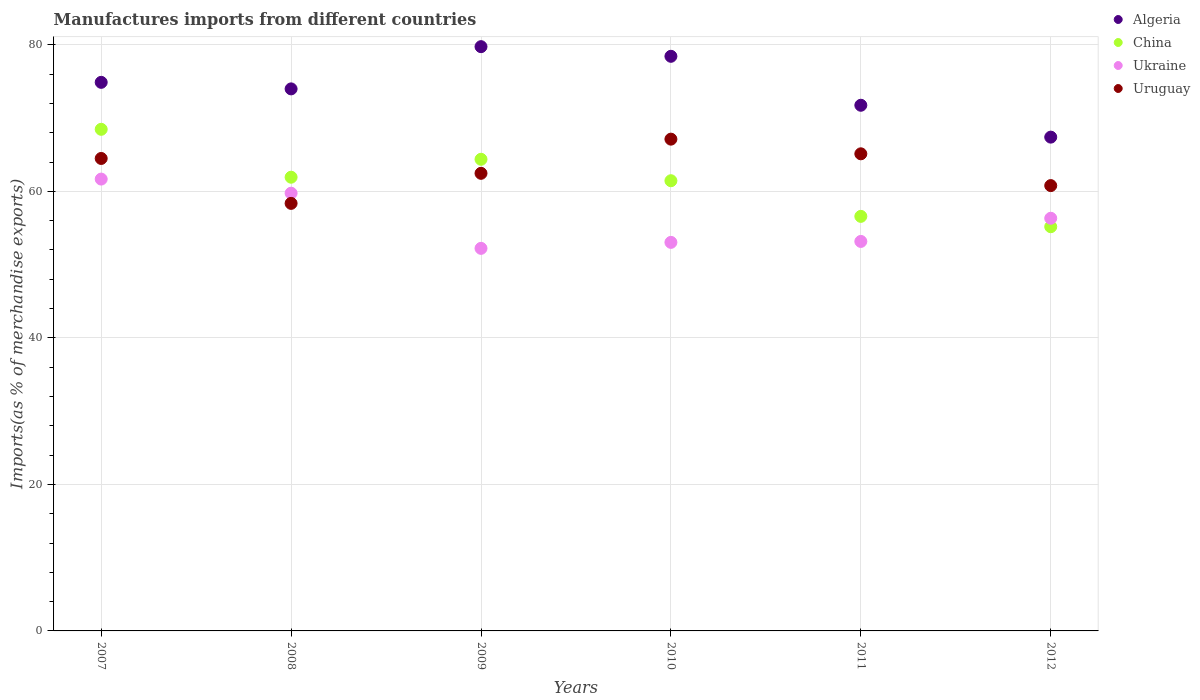How many different coloured dotlines are there?
Ensure brevity in your answer.  4. Is the number of dotlines equal to the number of legend labels?
Offer a very short reply. Yes. What is the percentage of imports to different countries in Uruguay in 2012?
Keep it short and to the point. 60.79. Across all years, what is the maximum percentage of imports to different countries in China?
Your answer should be very brief. 68.47. Across all years, what is the minimum percentage of imports to different countries in China?
Offer a very short reply. 55.17. What is the total percentage of imports to different countries in Uruguay in the graph?
Offer a very short reply. 378.35. What is the difference between the percentage of imports to different countries in Algeria in 2008 and that in 2010?
Provide a short and direct response. -4.45. What is the difference between the percentage of imports to different countries in Ukraine in 2011 and the percentage of imports to different countries in Algeria in 2012?
Offer a terse response. -14.24. What is the average percentage of imports to different countries in China per year?
Offer a terse response. 61.33. In the year 2007, what is the difference between the percentage of imports to different countries in Uruguay and percentage of imports to different countries in Ukraine?
Your response must be concise. 2.81. In how many years, is the percentage of imports to different countries in Uruguay greater than 32 %?
Provide a succinct answer. 6. What is the ratio of the percentage of imports to different countries in Uruguay in 2008 to that in 2009?
Provide a succinct answer. 0.93. Is the percentage of imports to different countries in Algeria in 2008 less than that in 2011?
Provide a succinct answer. No. Is the difference between the percentage of imports to different countries in Uruguay in 2008 and 2012 greater than the difference between the percentage of imports to different countries in Ukraine in 2008 and 2012?
Give a very brief answer. No. What is the difference between the highest and the second highest percentage of imports to different countries in China?
Offer a terse response. 4.09. What is the difference between the highest and the lowest percentage of imports to different countries in Ukraine?
Ensure brevity in your answer.  9.46. Is the sum of the percentage of imports to different countries in China in 2008 and 2012 greater than the maximum percentage of imports to different countries in Ukraine across all years?
Keep it short and to the point. Yes. Is it the case that in every year, the sum of the percentage of imports to different countries in China and percentage of imports to different countries in Uruguay  is greater than the sum of percentage of imports to different countries in Ukraine and percentage of imports to different countries in Algeria?
Your answer should be compact. No. Is the percentage of imports to different countries in China strictly less than the percentage of imports to different countries in Algeria over the years?
Offer a terse response. Yes. How many dotlines are there?
Provide a short and direct response. 4. Are the values on the major ticks of Y-axis written in scientific E-notation?
Keep it short and to the point. No. Does the graph contain grids?
Keep it short and to the point. Yes. How many legend labels are there?
Give a very brief answer. 4. What is the title of the graph?
Offer a terse response. Manufactures imports from different countries. What is the label or title of the Y-axis?
Provide a succinct answer. Imports(as % of merchandise exports). What is the Imports(as % of merchandise exports) of Algeria in 2007?
Provide a succinct answer. 74.88. What is the Imports(as % of merchandise exports) of China in 2007?
Your answer should be compact. 68.47. What is the Imports(as % of merchandise exports) of Ukraine in 2007?
Keep it short and to the point. 61.68. What is the Imports(as % of merchandise exports) of Uruguay in 2007?
Give a very brief answer. 64.49. What is the Imports(as % of merchandise exports) of Algeria in 2008?
Keep it short and to the point. 73.99. What is the Imports(as % of merchandise exports) in China in 2008?
Provide a short and direct response. 61.93. What is the Imports(as % of merchandise exports) in Ukraine in 2008?
Your response must be concise. 59.75. What is the Imports(as % of merchandise exports) in Uruguay in 2008?
Provide a short and direct response. 58.36. What is the Imports(as % of merchandise exports) of Algeria in 2009?
Provide a short and direct response. 79.75. What is the Imports(as % of merchandise exports) in China in 2009?
Your response must be concise. 64.38. What is the Imports(as % of merchandise exports) in Ukraine in 2009?
Offer a terse response. 52.22. What is the Imports(as % of merchandise exports) of Uruguay in 2009?
Make the answer very short. 62.46. What is the Imports(as % of merchandise exports) in Algeria in 2010?
Offer a very short reply. 78.43. What is the Imports(as % of merchandise exports) in China in 2010?
Offer a terse response. 61.45. What is the Imports(as % of merchandise exports) in Ukraine in 2010?
Provide a short and direct response. 53.04. What is the Imports(as % of merchandise exports) in Uruguay in 2010?
Offer a very short reply. 67.13. What is the Imports(as % of merchandise exports) in Algeria in 2011?
Keep it short and to the point. 71.75. What is the Imports(as % of merchandise exports) in China in 2011?
Provide a short and direct response. 56.59. What is the Imports(as % of merchandise exports) in Ukraine in 2011?
Your answer should be very brief. 53.16. What is the Imports(as % of merchandise exports) in Uruguay in 2011?
Offer a terse response. 65.12. What is the Imports(as % of merchandise exports) of Algeria in 2012?
Your answer should be very brief. 67.4. What is the Imports(as % of merchandise exports) in China in 2012?
Offer a very short reply. 55.17. What is the Imports(as % of merchandise exports) in Ukraine in 2012?
Offer a very short reply. 56.33. What is the Imports(as % of merchandise exports) of Uruguay in 2012?
Give a very brief answer. 60.79. Across all years, what is the maximum Imports(as % of merchandise exports) of Algeria?
Your answer should be very brief. 79.75. Across all years, what is the maximum Imports(as % of merchandise exports) of China?
Ensure brevity in your answer.  68.47. Across all years, what is the maximum Imports(as % of merchandise exports) of Ukraine?
Give a very brief answer. 61.68. Across all years, what is the maximum Imports(as % of merchandise exports) in Uruguay?
Offer a terse response. 67.13. Across all years, what is the minimum Imports(as % of merchandise exports) of Algeria?
Your response must be concise. 67.4. Across all years, what is the minimum Imports(as % of merchandise exports) in China?
Give a very brief answer. 55.17. Across all years, what is the minimum Imports(as % of merchandise exports) of Ukraine?
Provide a short and direct response. 52.22. Across all years, what is the minimum Imports(as % of merchandise exports) of Uruguay?
Offer a very short reply. 58.36. What is the total Imports(as % of merchandise exports) of Algeria in the graph?
Your answer should be very brief. 446.2. What is the total Imports(as % of merchandise exports) in China in the graph?
Provide a short and direct response. 367.98. What is the total Imports(as % of merchandise exports) of Ukraine in the graph?
Ensure brevity in your answer.  336.17. What is the total Imports(as % of merchandise exports) of Uruguay in the graph?
Keep it short and to the point. 378.35. What is the difference between the Imports(as % of merchandise exports) in Algeria in 2007 and that in 2008?
Provide a succinct answer. 0.89. What is the difference between the Imports(as % of merchandise exports) in China in 2007 and that in 2008?
Your answer should be very brief. 6.54. What is the difference between the Imports(as % of merchandise exports) in Ukraine in 2007 and that in 2008?
Provide a succinct answer. 1.93. What is the difference between the Imports(as % of merchandise exports) of Uruguay in 2007 and that in 2008?
Your response must be concise. 6.13. What is the difference between the Imports(as % of merchandise exports) in Algeria in 2007 and that in 2009?
Offer a terse response. -4.87. What is the difference between the Imports(as % of merchandise exports) of China in 2007 and that in 2009?
Provide a short and direct response. 4.09. What is the difference between the Imports(as % of merchandise exports) in Ukraine in 2007 and that in 2009?
Your answer should be compact. 9.46. What is the difference between the Imports(as % of merchandise exports) in Uruguay in 2007 and that in 2009?
Your answer should be very brief. 2.03. What is the difference between the Imports(as % of merchandise exports) of Algeria in 2007 and that in 2010?
Your answer should be very brief. -3.55. What is the difference between the Imports(as % of merchandise exports) in China in 2007 and that in 2010?
Your answer should be compact. 7.02. What is the difference between the Imports(as % of merchandise exports) of Ukraine in 2007 and that in 2010?
Ensure brevity in your answer.  8.64. What is the difference between the Imports(as % of merchandise exports) of Uruguay in 2007 and that in 2010?
Keep it short and to the point. -2.64. What is the difference between the Imports(as % of merchandise exports) in Algeria in 2007 and that in 2011?
Your response must be concise. 3.13. What is the difference between the Imports(as % of merchandise exports) in China in 2007 and that in 2011?
Your answer should be very brief. 11.88. What is the difference between the Imports(as % of merchandise exports) of Ukraine in 2007 and that in 2011?
Your answer should be compact. 8.51. What is the difference between the Imports(as % of merchandise exports) of Uruguay in 2007 and that in 2011?
Provide a succinct answer. -0.64. What is the difference between the Imports(as % of merchandise exports) in Algeria in 2007 and that in 2012?
Offer a very short reply. 7.48. What is the difference between the Imports(as % of merchandise exports) in China in 2007 and that in 2012?
Keep it short and to the point. 13.3. What is the difference between the Imports(as % of merchandise exports) in Ukraine in 2007 and that in 2012?
Offer a terse response. 5.35. What is the difference between the Imports(as % of merchandise exports) of Uruguay in 2007 and that in 2012?
Make the answer very short. 3.7. What is the difference between the Imports(as % of merchandise exports) of Algeria in 2008 and that in 2009?
Provide a succinct answer. -5.76. What is the difference between the Imports(as % of merchandise exports) of China in 2008 and that in 2009?
Provide a succinct answer. -2.45. What is the difference between the Imports(as % of merchandise exports) of Ukraine in 2008 and that in 2009?
Give a very brief answer. 7.53. What is the difference between the Imports(as % of merchandise exports) of Uruguay in 2008 and that in 2009?
Give a very brief answer. -4.1. What is the difference between the Imports(as % of merchandise exports) of Algeria in 2008 and that in 2010?
Your answer should be very brief. -4.45. What is the difference between the Imports(as % of merchandise exports) in China in 2008 and that in 2010?
Offer a terse response. 0.48. What is the difference between the Imports(as % of merchandise exports) in Ukraine in 2008 and that in 2010?
Offer a very short reply. 6.71. What is the difference between the Imports(as % of merchandise exports) of Uruguay in 2008 and that in 2010?
Provide a short and direct response. -8.77. What is the difference between the Imports(as % of merchandise exports) of Algeria in 2008 and that in 2011?
Ensure brevity in your answer.  2.23. What is the difference between the Imports(as % of merchandise exports) in China in 2008 and that in 2011?
Provide a short and direct response. 5.34. What is the difference between the Imports(as % of merchandise exports) in Ukraine in 2008 and that in 2011?
Your answer should be very brief. 6.59. What is the difference between the Imports(as % of merchandise exports) of Uruguay in 2008 and that in 2011?
Offer a very short reply. -6.77. What is the difference between the Imports(as % of merchandise exports) of Algeria in 2008 and that in 2012?
Your response must be concise. 6.58. What is the difference between the Imports(as % of merchandise exports) in China in 2008 and that in 2012?
Keep it short and to the point. 6.76. What is the difference between the Imports(as % of merchandise exports) in Ukraine in 2008 and that in 2012?
Give a very brief answer. 3.42. What is the difference between the Imports(as % of merchandise exports) of Uruguay in 2008 and that in 2012?
Your response must be concise. -2.43. What is the difference between the Imports(as % of merchandise exports) of Algeria in 2009 and that in 2010?
Your answer should be compact. 1.32. What is the difference between the Imports(as % of merchandise exports) in China in 2009 and that in 2010?
Ensure brevity in your answer.  2.93. What is the difference between the Imports(as % of merchandise exports) of Ukraine in 2009 and that in 2010?
Give a very brief answer. -0.82. What is the difference between the Imports(as % of merchandise exports) of Uruguay in 2009 and that in 2010?
Your answer should be very brief. -4.66. What is the difference between the Imports(as % of merchandise exports) of Algeria in 2009 and that in 2011?
Your response must be concise. 8. What is the difference between the Imports(as % of merchandise exports) of China in 2009 and that in 2011?
Offer a terse response. 7.79. What is the difference between the Imports(as % of merchandise exports) of Ukraine in 2009 and that in 2011?
Provide a short and direct response. -0.95. What is the difference between the Imports(as % of merchandise exports) in Uruguay in 2009 and that in 2011?
Your answer should be very brief. -2.66. What is the difference between the Imports(as % of merchandise exports) of Algeria in 2009 and that in 2012?
Keep it short and to the point. 12.35. What is the difference between the Imports(as % of merchandise exports) in China in 2009 and that in 2012?
Give a very brief answer. 9.2. What is the difference between the Imports(as % of merchandise exports) in Ukraine in 2009 and that in 2012?
Offer a terse response. -4.11. What is the difference between the Imports(as % of merchandise exports) in Uruguay in 2009 and that in 2012?
Your response must be concise. 1.68. What is the difference between the Imports(as % of merchandise exports) in Algeria in 2010 and that in 2011?
Your answer should be very brief. 6.68. What is the difference between the Imports(as % of merchandise exports) in China in 2010 and that in 2011?
Offer a terse response. 4.87. What is the difference between the Imports(as % of merchandise exports) of Ukraine in 2010 and that in 2011?
Provide a succinct answer. -0.13. What is the difference between the Imports(as % of merchandise exports) of Uruguay in 2010 and that in 2011?
Offer a very short reply. 2. What is the difference between the Imports(as % of merchandise exports) in Algeria in 2010 and that in 2012?
Your response must be concise. 11.03. What is the difference between the Imports(as % of merchandise exports) of China in 2010 and that in 2012?
Your response must be concise. 6.28. What is the difference between the Imports(as % of merchandise exports) in Ukraine in 2010 and that in 2012?
Your response must be concise. -3.29. What is the difference between the Imports(as % of merchandise exports) in Uruguay in 2010 and that in 2012?
Provide a short and direct response. 6.34. What is the difference between the Imports(as % of merchandise exports) of Algeria in 2011 and that in 2012?
Your answer should be very brief. 4.35. What is the difference between the Imports(as % of merchandise exports) in China in 2011 and that in 2012?
Your answer should be very brief. 1.41. What is the difference between the Imports(as % of merchandise exports) of Ukraine in 2011 and that in 2012?
Your answer should be compact. -3.16. What is the difference between the Imports(as % of merchandise exports) of Uruguay in 2011 and that in 2012?
Make the answer very short. 4.34. What is the difference between the Imports(as % of merchandise exports) in Algeria in 2007 and the Imports(as % of merchandise exports) in China in 2008?
Your answer should be very brief. 12.95. What is the difference between the Imports(as % of merchandise exports) of Algeria in 2007 and the Imports(as % of merchandise exports) of Ukraine in 2008?
Offer a terse response. 15.13. What is the difference between the Imports(as % of merchandise exports) of Algeria in 2007 and the Imports(as % of merchandise exports) of Uruguay in 2008?
Your answer should be very brief. 16.52. What is the difference between the Imports(as % of merchandise exports) in China in 2007 and the Imports(as % of merchandise exports) in Ukraine in 2008?
Offer a terse response. 8.72. What is the difference between the Imports(as % of merchandise exports) in China in 2007 and the Imports(as % of merchandise exports) in Uruguay in 2008?
Ensure brevity in your answer.  10.11. What is the difference between the Imports(as % of merchandise exports) of Ukraine in 2007 and the Imports(as % of merchandise exports) of Uruguay in 2008?
Your answer should be very brief. 3.32. What is the difference between the Imports(as % of merchandise exports) in Algeria in 2007 and the Imports(as % of merchandise exports) in China in 2009?
Keep it short and to the point. 10.5. What is the difference between the Imports(as % of merchandise exports) in Algeria in 2007 and the Imports(as % of merchandise exports) in Ukraine in 2009?
Provide a short and direct response. 22.66. What is the difference between the Imports(as % of merchandise exports) in Algeria in 2007 and the Imports(as % of merchandise exports) in Uruguay in 2009?
Your response must be concise. 12.42. What is the difference between the Imports(as % of merchandise exports) of China in 2007 and the Imports(as % of merchandise exports) of Ukraine in 2009?
Provide a short and direct response. 16.25. What is the difference between the Imports(as % of merchandise exports) in China in 2007 and the Imports(as % of merchandise exports) in Uruguay in 2009?
Ensure brevity in your answer.  6.01. What is the difference between the Imports(as % of merchandise exports) of Ukraine in 2007 and the Imports(as % of merchandise exports) of Uruguay in 2009?
Your answer should be very brief. -0.79. What is the difference between the Imports(as % of merchandise exports) of Algeria in 2007 and the Imports(as % of merchandise exports) of China in 2010?
Provide a short and direct response. 13.43. What is the difference between the Imports(as % of merchandise exports) in Algeria in 2007 and the Imports(as % of merchandise exports) in Ukraine in 2010?
Provide a succinct answer. 21.84. What is the difference between the Imports(as % of merchandise exports) of Algeria in 2007 and the Imports(as % of merchandise exports) of Uruguay in 2010?
Keep it short and to the point. 7.75. What is the difference between the Imports(as % of merchandise exports) in China in 2007 and the Imports(as % of merchandise exports) in Ukraine in 2010?
Keep it short and to the point. 15.43. What is the difference between the Imports(as % of merchandise exports) in China in 2007 and the Imports(as % of merchandise exports) in Uruguay in 2010?
Make the answer very short. 1.34. What is the difference between the Imports(as % of merchandise exports) of Ukraine in 2007 and the Imports(as % of merchandise exports) of Uruguay in 2010?
Offer a terse response. -5.45. What is the difference between the Imports(as % of merchandise exports) in Algeria in 2007 and the Imports(as % of merchandise exports) in China in 2011?
Make the answer very short. 18.29. What is the difference between the Imports(as % of merchandise exports) of Algeria in 2007 and the Imports(as % of merchandise exports) of Ukraine in 2011?
Keep it short and to the point. 21.72. What is the difference between the Imports(as % of merchandise exports) in Algeria in 2007 and the Imports(as % of merchandise exports) in Uruguay in 2011?
Ensure brevity in your answer.  9.76. What is the difference between the Imports(as % of merchandise exports) in China in 2007 and the Imports(as % of merchandise exports) in Ukraine in 2011?
Your answer should be compact. 15.3. What is the difference between the Imports(as % of merchandise exports) in China in 2007 and the Imports(as % of merchandise exports) in Uruguay in 2011?
Provide a succinct answer. 3.34. What is the difference between the Imports(as % of merchandise exports) in Ukraine in 2007 and the Imports(as % of merchandise exports) in Uruguay in 2011?
Give a very brief answer. -3.45. What is the difference between the Imports(as % of merchandise exports) in Algeria in 2007 and the Imports(as % of merchandise exports) in China in 2012?
Your answer should be very brief. 19.71. What is the difference between the Imports(as % of merchandise exports) in Algeria in 2007 and the Imports(as % of merchandise exports) in Ukraine in 2012?
Provide a succinct answer. 18.55. What is the difference between the Imports(as % of merchandise exports) of Algeria in 2007 and the Imports(as % of merchandise exports) of Uruguay in 2012?
Your response must be concise. 14.09. What is the difference between the Imports(as % of merchandise exports) in China in 2007 and the Imports(as % of merchandise exports) in Ukraine in 2012?
Ensure brevity in your answer.  12.14. What is the difference between the Imports(as % of merchandise exports) in China in 2007 and the Imports(as % of merchandise exports) in Uruguay in 2012?
Keep it short and to the point. 7.68. What is the difference between the Imports(as % of merchandise exports) in Ukraine in 2007 and the Imports(as % of merchandise exports) in Uruguay in 2012?
Ensure brevity in your answer.  0.89. What is the difference between the Imports(as % of merchandise exports) of Algeria in 2008 and the Imports(as % of merchandise exports) of China in 2009?
Provide a short and direct response. 9.61. What is the difference between the Imports(as % of merchandise exports) in Algeria in 2008 and the Imports(as % of merchandise exports) in Ukraine in 2009?
Provide a short and direct response. 21.77. What is the difference between the Imports(as % of merchandise exports) in Algeria in 2008 and the Imports(as % of merchandise exports) in Uruguay in 2009?
Keep it short and to the point. 11.53. What is the difference between the Imports(as % of merchandise exports) of China in 2008 and the Imports(as % of merchandise exports) of Ukraine in 2009?
Your answer should be compact. 9.71. What is the difference between the Imports(as % of merchandise exports) of China in 2008 and the Imports(as % of merchandise exports) of Uruguay in 2009?
Provide a succinct answer. -0.53. What is the difference between the Imports(as % of merchandise exports) of Ukraine in 2008 and the Imports(as % of merchandise exports) of Uruguay in 2009?
Ensure brevity in your answer.  -2.71. What is the difference between the Imports(as % of merchandise exports) in Algeria in 2008 and the Imports(as % of merchandise exports) in China in 2010?
Provide a short and direct response. 12.54. What is the difference between the Imports(as % of merchandise exports) in Algeria in 2008 and the Imports(as % of merchandise exports) in Ukraine in 2010?
Your answer should be very brief. 20.95. What is the difference between the Imports(as % of merchandise exports) in Algeria in 2008 and the Imports(as % of merchandise exports) in Uruguay in 2010?
Give a very brief answer. 6.86. What is the difference between the Imports(as % of merchandise exports) in China in 2008 and the Imports(as % of merchandise exports) in Ukraine in 2010?
Offer a very short reply. 8.89. What is the difference between the Imports(as % of merchandise exports) of China in 2008 and the Imports(as % of merchandise exports) of Uruguay in 2010?
Offer a terse response. -5.2. What is the difference between the Imports(as % of merchandise exports) in Ukraine in 2008 and the Imports(as % of merchandise exports) in Uruguay in 2010?
Your response must be concise. -7.38. What is the difference between the Imports(as % of merchandise exports) of Algeria in 2008 and the Imports(as % of merchandise exports) of China in 2011?
Offer a very short reply. 17.4. What is the difference between the Imports(as % of merchandise exports) of Algeria in 2008 and the Imports(as % of merchandise exports) of Ukraine in 2011?
Your answer should be compact. 20.82. What is the difference between the Imports(as % of merchandise exports) in Algeria in 2008 and the Imports(as % of merchandise exports) in Uruguay in 2011?
Your answer should be compact. 8.86. What is the difference between the Imports(as % of merchandise exports) of China in 2008 and the Imports(as % of merchandise exports) of Ukraine in 2011?
Provide a short and direct response. 8.77. What is the difference between the Imports(as % of merchandise exports) in China in 2008 and the Imports(as % of merchandise exports) in Uruguay in 2011?
Make the answer very short. -3.19. What is the difference between the Imports(as % of merchandise exports) in Ukraine in 2008 and the Imports(as % of merchandise exports) in Uruguay in 2011?
Keep it short and to the point. -5.37. What is the difference between the Imports(as % of merchandise exports) of Algeria in 2008 and the Imports(as % of merchandise exports) of China in 2012?
Your response must be concise. 18.81. What is the difference between the Imports(as % of merchandise exports) of Algeria in 2008 and the Imports(as % of merchandise exports) of Ukraine in 2012?
Give a very brief answer. 17.66. What is the difference between the Imports(as % of merchandise exports) in Algeria in 2008 and the Imports(as % of merchandise exports) in Uruguay in 2012?
Offer a terse response. 13.2. What is the difference between the Imports(as % of merchandise exports) of China in 2008 and the Imports(as % of merchandise exports) of Ukraine in 2012?
Provide a succinct answer. 5.6. What is the difference between the Imports(as % of merchandise exports) in China in 2008 and the Imports(as % of merchandise exports) in Uruguay in 2012?
Your answer should be compact. 1.15. What is the difference between the Imports(as % of merchandise exports) in Ukraine in 2008 and the Imports(as % of merchandise exports) in Uruguay in 2012?
Offer a very short reply. -1.04. What is the difference between the Imports(as % of merchandise exports) in Algeria in 2009 and the Imports(as % of merchandise exports) in China in 2010?
Offer a very short reply. 18.3. What is the difference between the Imports(as % of merchandise exports) of Algeria in 2009 and the Imports(as % of merchandise exports) of Ukraine in 2010?
Make the answer very short. 26.71. What is the difference between the Imports(as % of merchandise exports) of Algeria in 2009 and the Imports(as % of merchandise exports) of Uruguay in 2010?
Offer a terse response. 12.62. What is the difference between the Imports(as % of merchandise exports) in China in 2009 and the Imports(as % of merchandise exports) in Ukraine in 2010?
Provide a succinct answer. 11.34. What is the difference between the Imports(as % of merchandise exports) of China in 2009 and the Imports(as % of merchandise exports) of Uruguay in 2010?
Your answer should be compact. -2.75. What is the difference between the Imports(as % of merchandise exports) of Ukraine in 2009 and the Imports(as % of merchandise exports) of Uruguay in 2010?
Make the answer very short. -14.91. What is the difference between the Imports(as % of merchandise exports) of Algeria in 2009 and the Imports(as % of merchandise exports) of China in 2011?
Make the answer very short. 23.17. What is the difference between the Imports(as % of merchandise exports) in Algeria in 2009 and the Imports(as % of merchandise exports) in Ukraine in 2011?
Make the answer very short. 26.59. What is the difference between the Imports(as % of merchandise exports) in Algeria in 2009 and the Imports(as % of merchandise exports) in Uruguay in 2011?
Provide a short and direct response. 14.63. What is the difference between the Imports(as % of merchandise exports) of China in 2009 and the Imports(as % of merchandise exports) of Ukraine in 2011?
Your response must be concise. 11.21. What is the difference between the Imports(as % of merchandise exports) of China in 2009 and the Imports(as % of merchandise exports) of Uruguay in 2011?
Your answer should be very brief. -0.75. What is the difference between the Imports(as % of merchandise exports) of Ukraine in 2009 and the Imports(as % of merchandise exports) of Uruguay in 2011?
Your answer should be compact. -12.91. What is the difference between the Imports(as % of merchandise exports) in Algeria in 2009 and the Imports(as % of merchandise exports) in China in 2012?
Make the answer very short. 24.58. What is the difference between the Imports(as % of merchandise exports) in Algeria in 2009 and the Imports(as % of merchandise exports) in Ukraine in 2012?
Your answer should be very brief. 23.42. What is the difference between the Imports(as % of merchandise exports) in Algeria in 2009 and the Imports(as % of merchandise exports) in Uruguay in 2012?
Your response must be concise. 18.97. What is the difference between the Imports(as % of merchandise exports) in China in 2009 and the Imports(as % of merchandise exports) in Ukraine in 2012?
Offer a very short reply. 8.05. What is the difference between the Imports(as % of merchandise exports) of China in 2009 and the Imports(as % of merchandise exports) of Uruguay in 2012?
Offer a very short reply. 3.59. What is the difference between the Imports(as % of merchandise exports) of Ukraine in 2009 and the Imports(as % of merchandise exports) of Uruguay in 2012?
Give a very brief answer. -8.57. What is the difference between the Imports(as % of merchandise exports) of Algeria in 2010 and the Imports(as % of merchandise exports) of China in 2011?
Ensure brevity in your answer.  21.85. What is the difference between the Imports(as % of merchandise exports) of Algeria in 2010 and the Imports(as % of merchandise exports) of Ukraine in 2011?
Provide a short and direct response. 25.27. What is the difference between the Imports(as % of merchandise exports) of Algeria in 2010 and the Imports(as % of merchandise exports) of Uruguay in 2011?
Offer a terse response. 13.31. What is the difference between the Imports(as % of merchandise exports) in China in 2010 and the Imports(as % of merchandise exports) in Ukraine in 2011?
Make the answer very short. 8.29. What is the difference between the Imports(as % of merchandise exports) in China in 2010 and the Imports(as % of merchandise exports) in Uruguay in 2011?
Make the answer very short. -3.67. What is the difference between the Imports(as % of merchandise exports) of Ukraine in 2010 and the Imports(as % of merchandise exports) of Uruguay in 2011?
Offer a very short reply. -12.09. What is the difference between the Imports(as % of merchandise exports) in Algeria in 2010 and the Imports(as % of merchandise exports) in China in 2012?
Offer a terse response. 23.26. What is the difference between the Imports(as % of merchandise exports) of Algeria in 2010 and the Imports(as % of merchandise exports) of Ukraine in 2012?
Provide a succinct answer. 22.11. What is the difference between the Imports(as % of merchandise exports) in Algeria in 2010 and the Imports(as % of merchandise exports) in Uruguay in 2012?
Keep it short and to the point. 17.65. What is the difference between the Imports(as % of merchandise exports) in China in 2010 and the Imports(as % of merchandise exports) in Ukraine in 2012?
Your answer should be very brief. 5.12. What is the difference between the Imports(as % of merchandise exports) of China in 2010 and the Imports(as % of merchandise exports) of Uruguay in 2012?
Your answer should be very brief. 0.67. What is the difference between the Imports(as % of merchandise exports) of Ukraine in 2010 and the Imports(as % of merchandise exports) of Uruguay in 2012?
Offer a terse response. -7.75. What is the difference between the Imports(as % of merchandise exports) of Algeria in 2011 and the Imports(as % of merchandise exports) of China in 2012?
Offer a very short reply. 16.58. What is the difference between the Imports(as % of merchandise exports) in Algeria in 2011 and the Imports(as % of merchandise exports) in Ukraine in 2012?
Offer a terse response. 15.43. What is the difference between the Imports(as % of merchandise exports) in Algeria in 2011 and the Imports(as % of merchandise exports) in Uruguay in 2012?
Ensure brevity in your answer.  10.97. What is the difference between the Imports(as % of merchandise exports) of China in 2011 and the Imports(as % of merchandise exports) of Ukraine in 2012?
Your answer should be very brief. 0.26. What is the difference between the Imports(as % of merchandise exports) of China in 2011 and the Imports(as % of merchandise exports) of Uruguay in 2012?
Ensure brevity in your answer.  -4.2. What is the difference between the Imports(as % of merchandise exports) of Ukraine in 2011 and the Imports(as % of merchandise exports) of Uruguay in 2012?
Offer a very short reply. -7.62. What is the average Imports(as % of merchandise exports) of Algeria per year?
Your response must be concise. 74.37. What is the average Imports(as % of merchandise exports) of China per year?
Offer a terse response. 61.33. What is the average Imports(as % of merchandise exports) in Ukraine per year?
Make the answer very short. 56.03. What is the average Imports(as % of merchandise exports) of Uruguay per year?
Give a very brief answer. 63.06. In the year 2007, what is the difference between the Imports(as % of merchandise exports) in Algeria and Imports(as % of merchandise exports) in China?
Make the answer very short. 6.41. In the year 2007, what is the difference between the Imports(as % of merchandise exports) in Algeria and Imports(as % of merchandise exports) in Ukraine?
Offer a terse response. 13.2. In the year 2007, what is the difference between the Imports(as % of merchandise exports) of Algeria and Imports(as % of merchandise exports) of Uruguay?
Keep it short and to the point. 10.39. In the year 2007, what is the difference between the Imports(as % of merchandise exports) of China and Imports(as % of merchandise exports) of Ukraine?
Provide a succinct answer. 6.79. In the year 2007, what is the difference between the Imports(as % of merchandise exports) of China and Imports(as % of merchandise exports) of Uruguay?
Your answer should be very brief. 3.98. In the year 2007, what is the difference between the Imports(as % of merchandise exports) of Ukraine and Imports(as % of merchandise exports) of Uruguay?
Offer a terse response. -2.81. In the year 2008, what is the difference between the Imports(as % of merchandise exports) of Algeria and Imports(as % of merchandise exports) of China?
Provide a short and direct response. 12.06. In the year 2008, what is the difference between the Imports(as % of merchandise exports) of Algeria and Imports(as % of merchandise exports) of Ukraine?
Give a very brief answer. 14.24. In the year 2008, what is the difference between the Imports(as % of merchandise exports) of Algeria and Imports(as % of merchandise exports) of Uruguay?
Keep it short and to the point. 15.63. In the year 2008, what is the difference between the Imports(as % of merchandise exports) of China and Imports(as % of merchandise exports) of Ukraine?
Provide a short and direct response. 2.18. In the year 2008, what is the difference between the Imports(as % of merchandise exports) of China and Imports(as % of merchandise exports) of Uruguay?
Your answer should be compact. 3.57. In the year 2008, what is the difference between the Imports(as % of merchandise exports) in Ukraine and Imports(as % of merchandise exports) in Uruguay?
Your answer should be very brief. 1.39. In the year 2009, what is the difference between the Imports(as % of merchandise exports) of Algeria and Imports(as % of merchandise exports) of China?
Keep it short and to the point. 15.37. In the year 2009, what is the difference between the Imports(as % of merchandise exports) in Algeria and Imports(as % of merchandise exports) in Ukraine?
Your answer should be compact. 27.53. In the year 2009, what is the difference between the Imports(as % of merchandise exports) in Algeria and Imports(as % of merchandise exports) in Uruguay?
Provide a succinct answer. 17.29. In the year 2009, what is the difference between the Imports(as % of merchandise exports) of China and Imports(as % of merchandise exports) of Ukraine?
Make the answer very short. 12.16. In the year 2009, what is the difference between the Imports(as % of merchandise exports) in China and Imports(as % of merchandise exports) in Uruguay?
Offer a terse response. 1.92. In the year 2009, what is the difference between the Imports(as % of merchandise exports) of Ukraine and Imports(as % of merchandise exports) of Uruguay?
Your answer should be compact. -10.24. In the year 2010, what is the difference between the Imports(as % of merchandise exports) of Algeria and Imports(as % of merchandise exports) of China?
Offer a terse response. 16.98. In the year 2010, what is the difference between the Imports(as % of merchandise exports) of Algeria and Imports(as % of merchandise exports) of Ukraine?
Your answer should be very brief. 25.4. In the year 2010, what is the difference between the Imports(as % of merchandise exports) in Algeria and Imports(as % of merchandise exports) in Uruguay?
Give a very brief answer. 11.31. In the year 2010, what is the difference between the Imports(as % of merchandise exports) in China and Imports(as % of merchandise exports) in Ukraine?
Your answer should be very brief. 8.41. In the year 2010, what is the difference between the Imports(as % of merchandise exports) of China and Imports(as % of merchandise exports) of Uruguay?
Your response must be concise. -5.68. In the year 2010, what is the difference between the Imports(as % of merchandise exports) of Ukraine and Imports(as % of merchandise exports) of Uruguay?
Provide a succinct answer. -14.09. In the year 2011, what is the difference between the Imports(as % of merchandise exports) of Algeria and Imports(as % of merchandise exports) of China?
Your answer should be compact. 15.17. In the year 2011, what is the difference between the Imports(as % of merchandise exports) in Algeria and Imports(as % of merchandise exports) in Ukraine?
Provide a short and direct response. 18.59. In the year 2011, what is the difference between the Imports(as % of merchandise exports) of Algeria and Imports(as % of merchandise exports) of Uruguay?
Your answer should be very brief. 6.63. In the year 2011, what is the difference between the Imports(as % of merchandise exports) in China and Imports(as % of merchandise exports) in Ukraine?
Your answer should be very brief. 3.42. In the year 2011, what is the difference between the Imports(as % of merchandise exports) in China and Imports(as % of merchandise exports) in Uruguay?
Keep it short and to the point. -8.54. In the year 2011, what is the difference between the Imports(as % of merchandise exports) of Ukraine and Imports(as % of merchandise exports) of Uruguay?
Provide a succinct answer. -11.96. In the year 2012, what is the difference between the Imports(as % of merchandise exports) of Algeria and Imports(as % of merchandise exports) of China?
Your answer should be very brief. 12.23. In the year 2012, what is the difference between the Imports(as % of merchandise exports) in Algeria and Imports(as % of merchandise exports) in Ukraine?
Your response must be concise. 11.08. In the year 2012, what is the difference between the Imports(as % of merchandise exports) of Algeria and Imports(as % of merchandise exports) of Uruguay?
Ensure brevity in your answer.  6.62. In the year 2012, what is the difference between the Imports(as % of merchandise exports) in China and Imports(as % of merchandise exports) in Ukraine?
Offer a terse response. -1.15. In the year 2012, what is the difference between the Imports(as % of merchandise exports) of China and Imports(as % of merchandise exports) of Uruguay?
Keep it short and to the point. -5.61. In the year 2012, what is the difference between the Imports(as % of merchandise exports) in Ukraine and Imports(as % of merchandise exports) in Uruguay?
Offer a terse response. -4.46. What is the ratio of the Imports(as % of merchandise exports) of Algeria in 2007 to that in 2008?
Your answer should be compact. 1.01. What is the ratio of the Imports(as % of merchandise exports) in China in 2007 to that in 2008?
Ensure brevity in your answer.  1.11. What is the ratio of the Imports(as % of merchandise exports) of Ukraine in 2007 to that in 2008?
Provide a succinct answer. 1.03. What is the ratio of the Imports(as % of merchandise exports) of Uruguay in 2007 to that in 2008?
Keep it short and to the point. 1.11. What is the ratio of the Imports(as % of merchandise exports) of Algeria in 2007 to that in 2009?
Make the answer very short. 0.94. What is the ratio of the Imports(as % of merchandise exports) of China in 2007 to that in 2009?
Offer a very short reply. 1.06. What is the ratio of the Imports(as % of merchandise exports) of Ukraine in 2007 to that in 2009?
Your answer should be very brief. 1.18. What is the ratio of the Imports(as % of merchandise exports) in Uruguay in 2007 to that in 2009?
Make the answer very short. 1.03. What is the ratio of the Imports(as % of merchandise exports) of Algeria in 2007 to that in 2010?
Offer a very short reply. 0.95. What is the ratio of the Imports(as % of merchandise exports) of China in 2007 to that in 2010?
Your answer should be very brief. 1.11. What is the ratio of the Imports(as % of merchandise exports) in Ukraine in 2007 to that in 2010?
Give a very brief answer. 1.16. What is the ratio of the Imports(as % of merchandise exports) of Uruguay in 2007 to that in 2010?
Your response must be concise. 0.96. What is the ratio of the Imports(as % of merchandise exports) in Algeria in 2007 to that in 2011?
Your answer should be very brief. 1.04. What is the ratio of the Imports(as % of merchandise exports) of China in 2007 to that in 2011?
Provide a succinct answer. 1.21. What is the ratio of the Imports(as % of merchandise exports) in Ukraine in 2007 to that in 2011?
Provide a succinct answer. 1.16. What is the ratio of the Imports(as % of merchandise exports) of Uruguay in 2007 to that in 2011?
Your answer should be very brief. 0.99. What is the ratio of the Imports(as % of merchandise exports) of Algeria in 2007 to that in 2012?
Make the answer very short. 1.11. What is the ratio of the Imports(as % of merchandise exports) in China in 2007 to that in 2012?
Your answer should be compact. 1.24. What is the ratio of the Imports(as % of merchandise exports) in Ukraine in 2007 to that in 2012?
Offer a very short reply. 1.09. What is the ratio of the Imports(as % of merchandise exports) of Uruguay in 2007 to that in 2012?
Ensure brevity in your answer.  1.06. What is the ratio of the Imports(as % of merchandise exports) in Algeria in 2008 to that in 2009?
Your answer should be very brief. 0.93. What is the ratio of the Imports(as % of merchandise exports) of Ukraine in 2008 to that in 2009?
Give a very brief answer. 1.14. What is the ratio of the Imports(as % of merchandise exports) of Uruguay in 2008 to that in 2009?
Provide a succinct answer. 0.93. What is the ratio of the Imports(as % of merchandise exports) of Algeria in 2008 to that in 2010?
Give a very brief answer. 0.94. What is the ratio of the Imports(as % of merchandise exports) of Ukraine in 2008 to that in 2010?
Make the answer very short. 1.13. What is the ratio of the Imports(as % of merchandise exports) of Uruguay in 2008 to that in 2010?
Ensure brevity in your answer.  0.87. What is the ratio of the Imports(as % of merchandise exports) in Algeria in 2008 to that in 2011?
Ensure brevity in your answer.  1.03. What is the ratio of the Imports(as % of merchandise exports) in China in 2008 to that in 2011?
Give a very brief answer. 1.09. What is the ratio of the Imports(as % of merchandise exports) in Ukraine in 2008 to that in 2011?
Make the answer very short. 1.12. What is the ratio of the Imports(as % of merchandise exports) of Uruguay in 2008 to that in 2011?
Ensure brevity in your answer.  0.9. What is the ratio of the Imports(as % of merchandise exports) in Algeria in 2008 to that in 2012?
Keep it short and to the point. 1.1. What is the ratio of the Imports(as % of merchandise exports) of China in 2008 to that in 2012?
Provide a succinct answer. 1.12. What is the ratio of the Imports(as % of merchandise exports) of Ukraine in 2008 to that in 2012?
Your response must be concise. 1.06. What is the ratio of the Imports(as % of merchandise exports) of Uruguay in 2008 to that in 2012?
Offer a terse response. 0.96. What is the ratio of the Imports(as % of merchandise exports) in Algeria in 2009 to that in 2010?
Provide a succinct answer. 1.02. What is the ratio of the Imports(as % of merchandise exports) of China in 2009 to that in 2010?
Make the answer very short. 1.05. What is the ratio of the Imports(as % of merchandise exports) in Ukraine in 2009 to that in 2010?
Offer a very short reply. 0.98. What is the ratio of the Imports(as % of merchandise exports) of Uruguay in 2009 to that in 2010?
Your answer should be very brief. 0.93. What is the ratio of the Imports(as % of merchandise exports) in Algeria in 2009 to that in 2011?
Provide a short and direct response. 1.11. What is the ratio of the Imports(as % of merchandise exports) in China in 2009 to that in 2011?
Your answer should be very brief. 1.14. What is the ratio of the Imports(as % of merchandise exports) in Ukraine in 2009 to that in 2011?
Make the answer very short. 0.98. What is the ratio of the Imports(as % of merchandise exports) in Uruguay in 2009 to that in 2011?
Give a very brief answer. 0.96. What is the ratio of the Imports(as % of merchandise exports) in Algeria in 2009 to that in 2012?
Your response must be concise. 1.18. What is the ratio of the Imports(as % of merchandise exports) in China in 2009 to that in 2012?
Make the answer very short. 1.17. What is the ratio of the Imports(as % of merchandise exports) in Ukraine in 2009 to that in 2012?
Provide a short and direct response. 0.93. What is the ratio of the Imports(as % of merchandise exports) of Uruguay in 2009 to that in 2012?
Make the answer very short. 1.03. What is the ratio of the Imports(as % of merchandise exports) of Algeria in 2010 to that in 2011?
Offer a very short reply. 1.09. What is the ratio of the Imports(as % of merchandise exports) of China in 2010 to that in 2011?
Provide a succinct answer. 1.09. What is the ratio of the Imports(as % of merchandise exports) of Uruguay in 2010 to that in 2011?
Ensure brevity in your answer.  1.03. What is the ratio of the Imports(as % of merchandise exports) in Algeria in 2010 to that in 2012?
Your response must be concise. 1.16. What is the ratio of the Imports(as % of merchandise exports) of China in 2010 to that in 2012?
Your answer should be compact. 1.11. What is the ratio of the Imports(as % of merchandise exports) of Ukraine in 2010 to that in 2012?
Ensure brevity in your answer.  0.94. What is the ratio of the Imports(as % of merchandise exports) in Uruguay in 2010 to that in 2012?
Make the answer very short. 1.1. What is the ratio of the Imports(as % of merchandise exports) of Algeria in 2011 to that in 2012?
Provide a succinct answer. 1.06. What is the ratio of the Imports(as % of merchandise exports) of China in 2011 to that in 2012?
Make the answer very short. 1.03. What is the ratio of the Imports(as % of merchandise exports) in Ukraine in 2011 to that in 2012?
Your response must be concise. 0.94. What is the ratio of the Imports(as % of merchandise exports) of Uruguay in 2011 to that in 2012?
Provide a short and direct response. 1.07. What is the difference between the highest and the second highest Imports(as % of merchandise exports) of Algeria?
Provide a short and direct response. 1.32. What is the difference between the highest and the second highest Imports(as % of merchandise exports) in China?
Offer a very short reply. 4.09. What is the difference between the highest and the second highest Imports(as % of merchandise exports) in Ukraine?
Provide a short and direct response. 1.93. What is the difference between the highest and the second highest Imports(as % of merchandise exports) in Uruguay?
Make the answer very short. 2. What is the difference between the highest and the lowest Imports(as % of merchandise exports) of Algeria?
Your answer should be very brief. 12.35. What is the difference between the highest and the lowest Imports(as % of merchandise exports) of China?
Provide a succinct answer. 13.3. What is the difference between the highest and the lowest Imports(as % of merchandise exports) in Ukraine?
Provide a short and direct response. 9.46. What is the difference between the highest and the lowest Imports(as % of merchandise exports) in Uruguay?
Give a very brief answer. 8.77. 